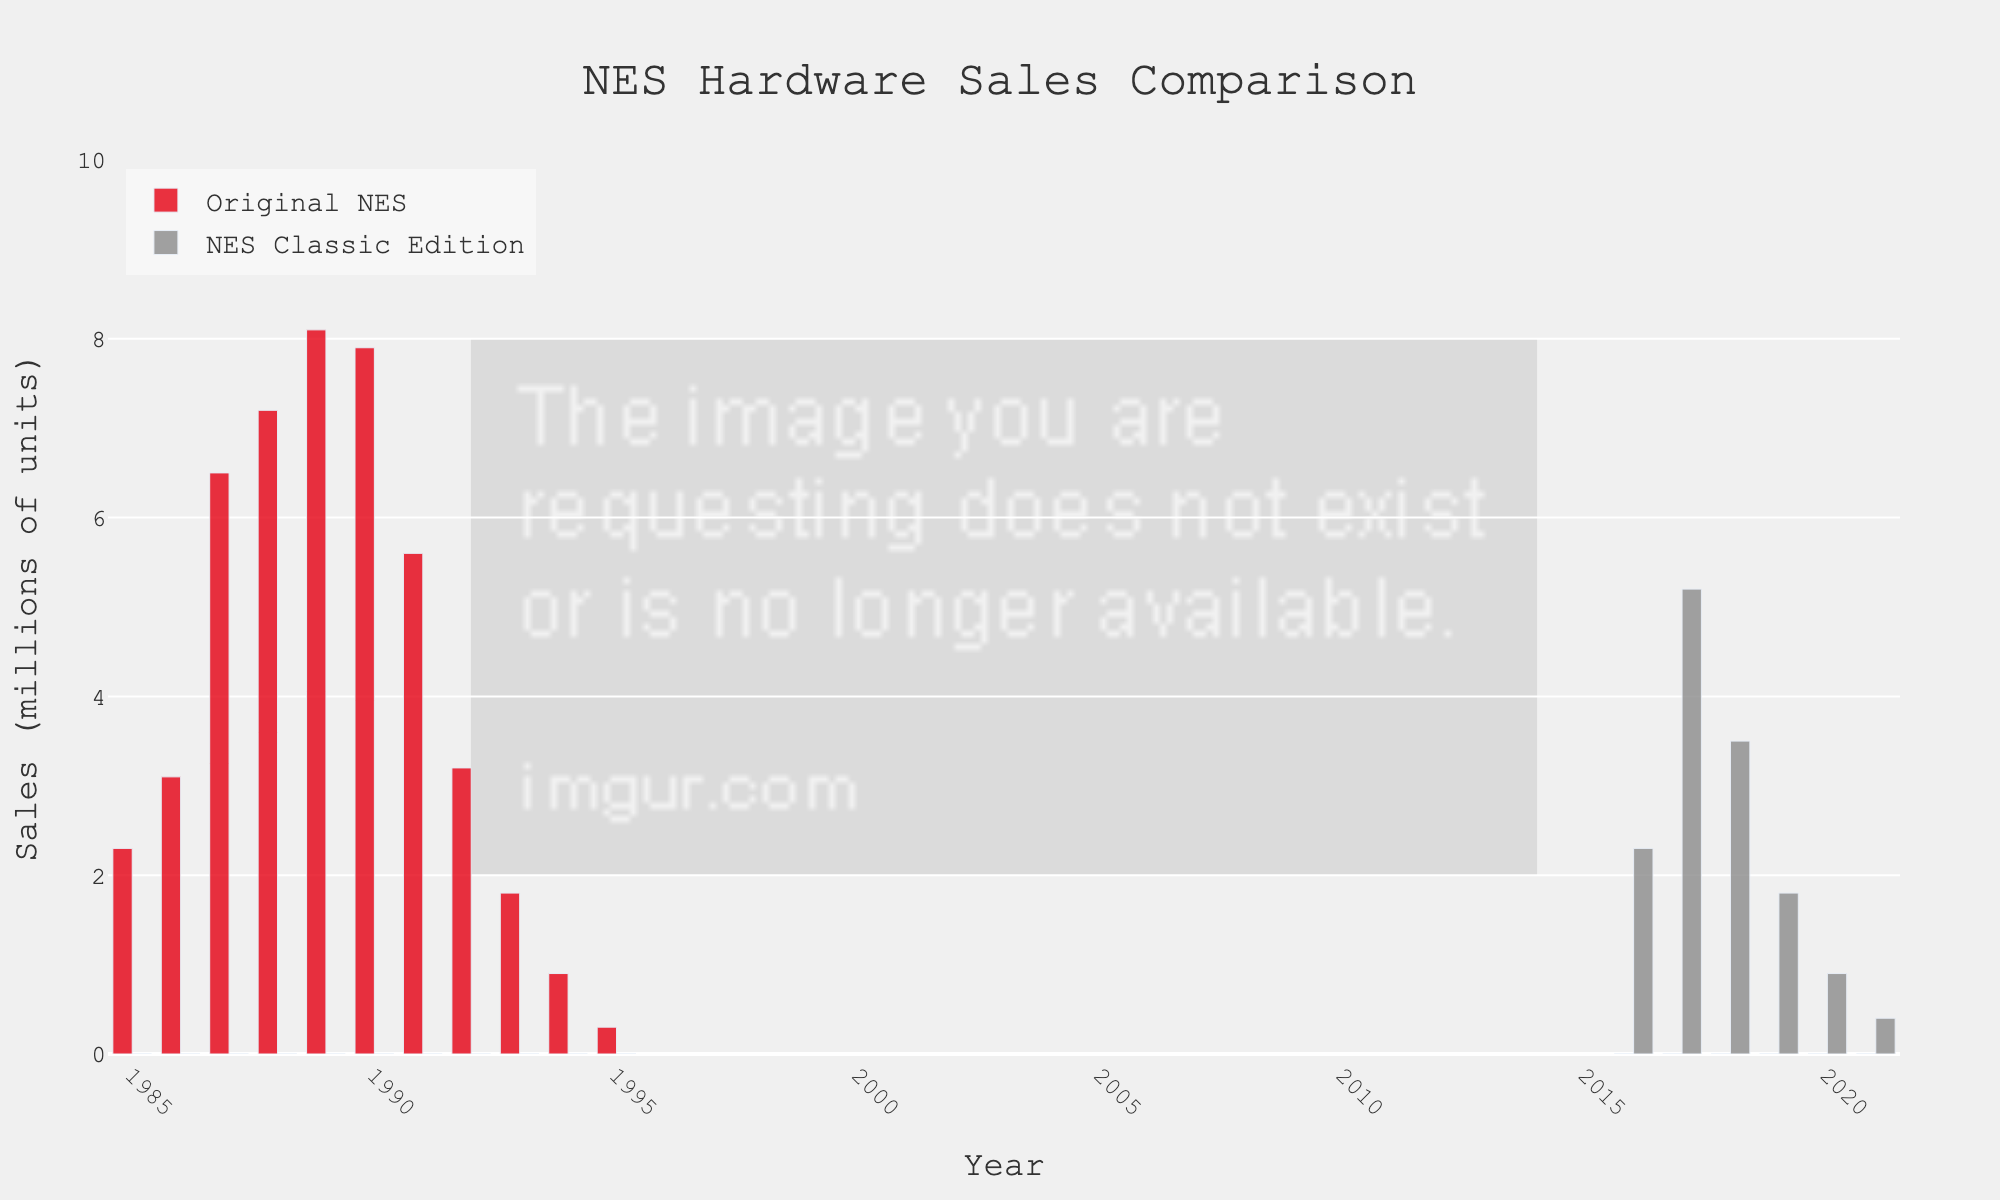What's the total sales of the Original NES in 1989 and 1990? To find the total sales for the years 1989 and 1990, sum up the sales for these two years. The sales for 1989 are 8.1 million, and for 1990 are 7.9 million. Summing these values: 8.1 + 7.9 = 16.0.
Answer: 16.0 Which year recorded the highest sales for the Original NES? To identify the year with the highest sales for the Original NES, look at the height of the bars representing the Original NES from 1985 to 1995. The tallest bar is in 1989, with sales of 8.1 million units.
Answer: 1989 How do the sales of the NES Classic Edition in 2017 compare to its sales in 2021? To compare the sales between these two years, look at the height of the bars for the NES Classic Edition in 2017 and 2021. The sales in 2017 are 5.2 million, while in 2021, they are 0.4 million. Therefore, sales in 2017 are much higher.
Answer: 2017 had higher sales What is the combined total sales of both the Original NES and the NES Classic Edition in their best-selling years? For the Original NES, the best-selling year is 1989 with 8.1 million units. For the NES Classic Edition, the best-selling year is 2017 with 5.2 million units. Adding these values gives: 8.1 + 5.2 = 13.3 million units.
Answer: 13.3 By how much did the sales of the Original NES decline from 1988 to 1991? To find the decline, subtract the sales in 1991 from the sales in 1988. The sales in 1988 are 7.2 million, and in 1991 they are 5.6 million. The decline is 7.2 - 5.6 = 1.6 million units.
Answer: 1.6 What is the average sales of the Original NES from 1985 to 1990? To calculate the average, sum the sales from 1985 to 1990 and divide by the number of years. The sales are: 2.3 (1985) + 3.1 (1986) + 6.5 (1987) + 7.2 (1988) + 8.1 (1989) + 7.9 (1990) = 35.1. The number of years is 6. So, 35.1 / 6 ≈ 5.85 million units.
Answer: 5.85 Which year had zero sales for both the Original NES and NES Classic Edition? Look for the year(s) where both the Original NES and NES Classic Edition bars are absent or have zero height. This occurs in 1985 for the NES Classic Edition and 2016-2021 for the Original NES. The only year with zero sales for both is 1985 for NES Classic Edition.
Answer: 1985 